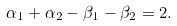<formula> <loc_0><loc_0><loc_500><loc_500>\alpha _ { 1 } + \alpha _ { 2 } - \beta _ { 1 } - \beta _ { 2 } = 2 .</formula> 